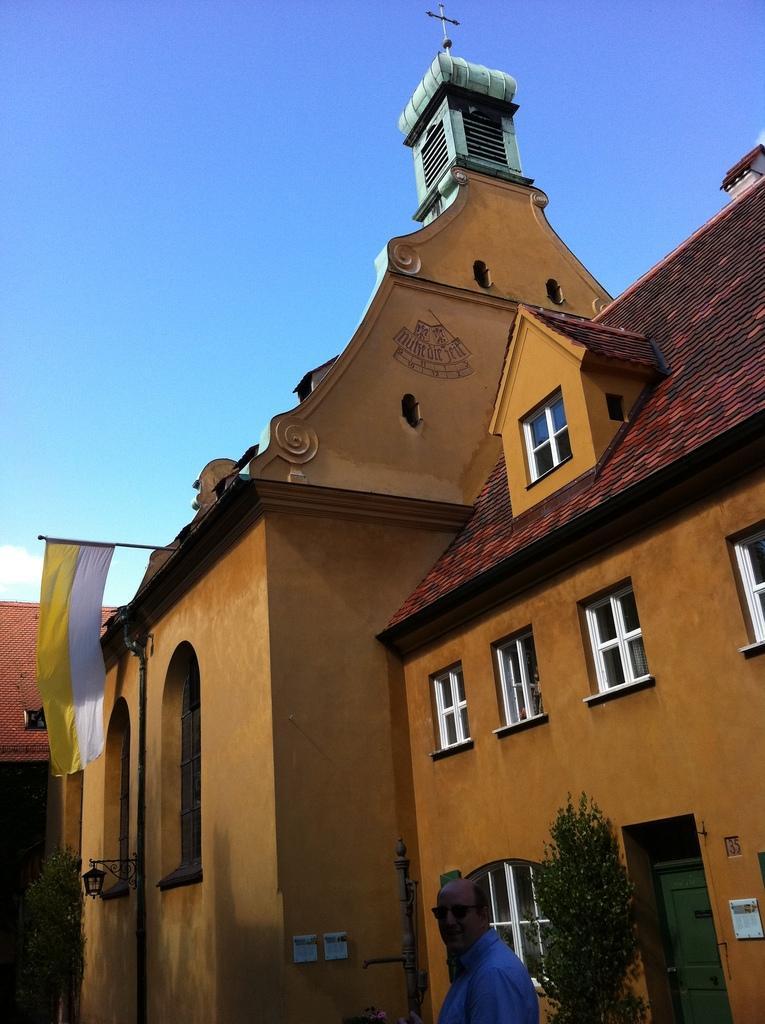Can you describe this image briefly? In this image there is a big building with cross on top and flag hanging on roof, in front of that there is a person walking on road tree in front of that. 